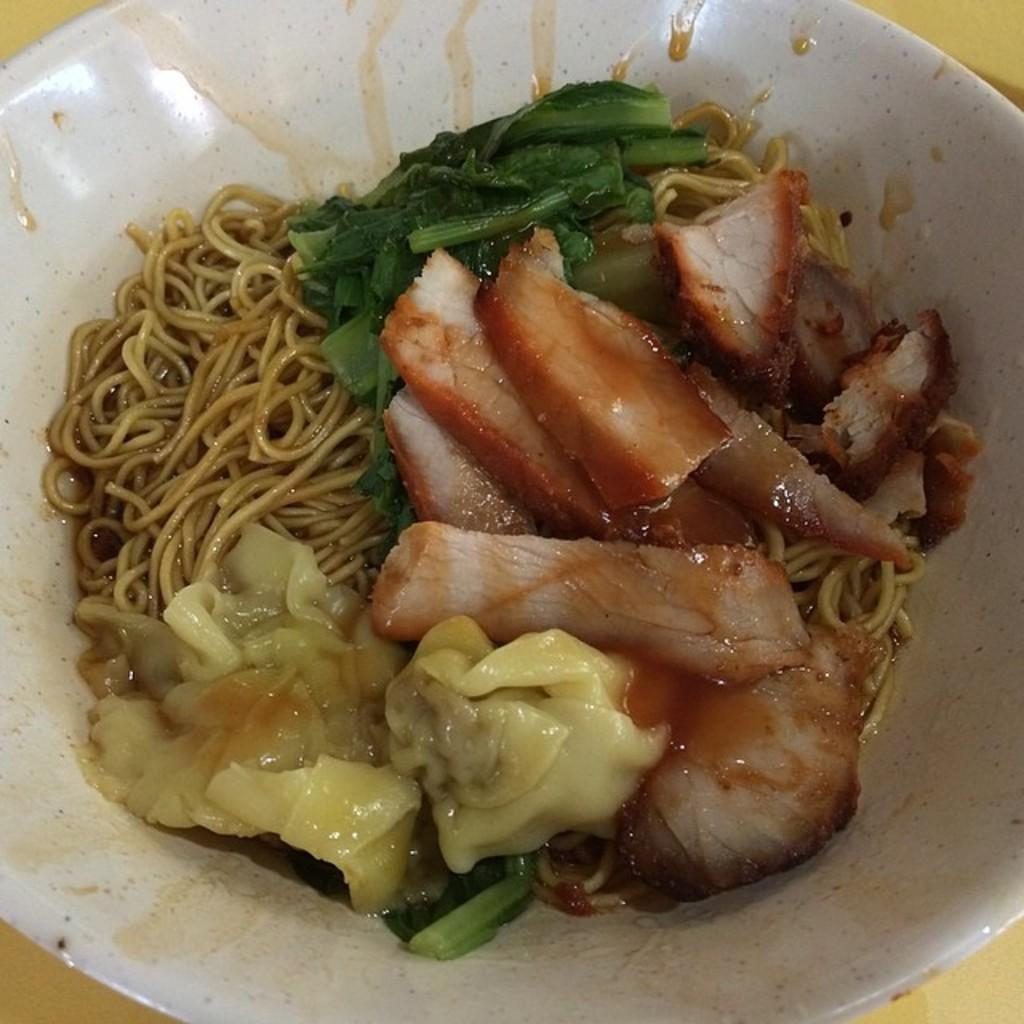What type of food is served in the bowl in the image? The food item served in the bowl contains spaghetti. What are some of the ingredients in the food item? The food item contains green leaves, meat, and other items. What type of crow is sitting on the nation's flag in the image? There is no crow or flag present in the image; it features a bowl of food with spaghetti, green leaves, meat, and other items. How many eggs are visible in the image? There are no eggs present in the image. 